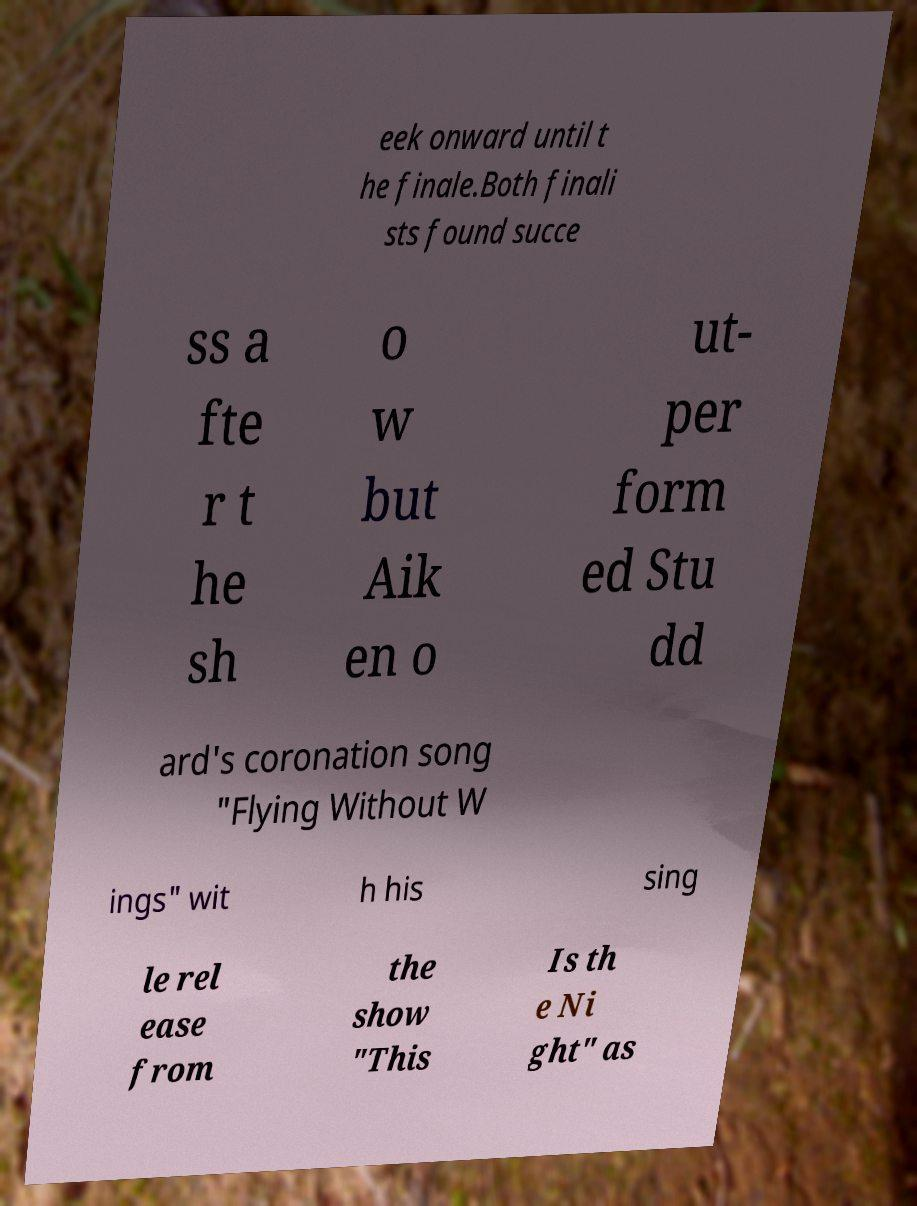Could you assist in decoding the text presented in this image and type it out clearly? eek onward until t he finale.Both finali sts found succe ss a fte r t he sh o w but Aik en o ut- per form ed Stu dd ard's coronation song "Flying Without W ings" wit h his sing le rel ease from the show "This Is th e Ni ght" as 